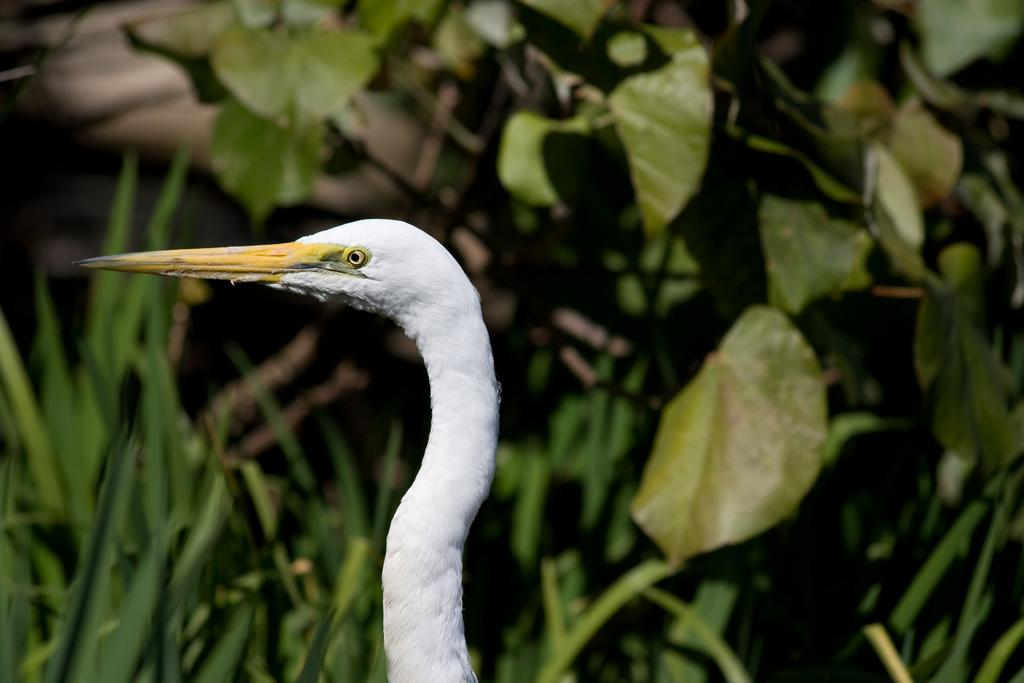What type of animal can be seen in the image? There is a bird in the image. What can be seen in the background of the image? There are plants in the background of the image. What type of rifle is the bird using to hunt in the image? There is no rifle present in the image, and the bird is not hunting. 